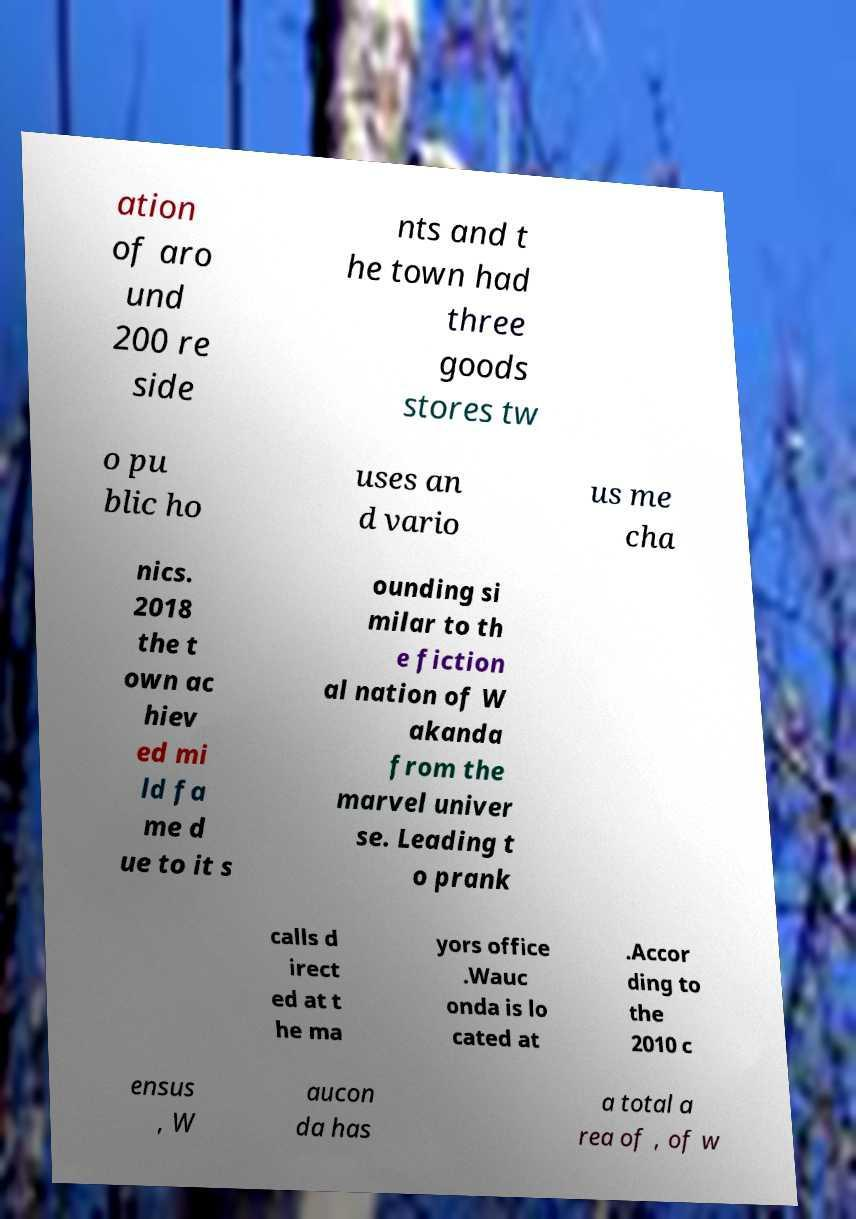Please read and relay the text visible in this image. What does it say? ation of aro und 200 re side nts and t he town had three goods stores tw o pu blic ho uses an d vario us me cha nics. 2018 the t own ac hiev ed mi ld fa me d ue to it s ounding si milar to th e fiction al nation of W akanda from the marvel univer se. Leading t o prank calls d irect ed at t he ma yors office .Wauc onda is lo cated at .Accor ding to the 2010 c ensus , W aucon da has a total a rea of , of w 